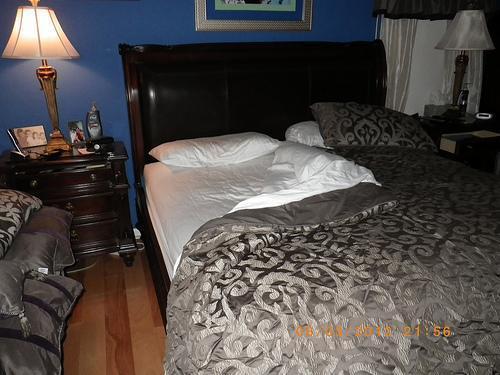How many drawers does the nightstand to the left have?
Give a very brief answer. 3. How many people are in the photo to the left on the nightstand?
Give a very brief answer. 4. How many lamps are turned on?
Give a very brief answer. 1. How many lamps are visible?
Give a very brief answer. 2. 